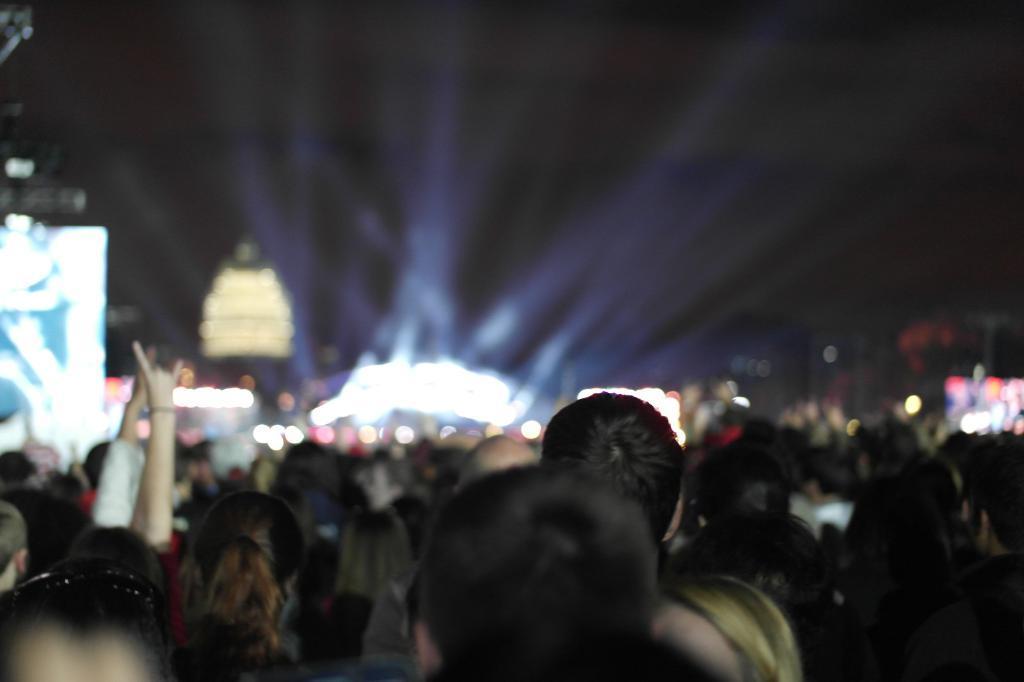Please provide a concise description of this image. In this image there are group of people, and there is blur background. 